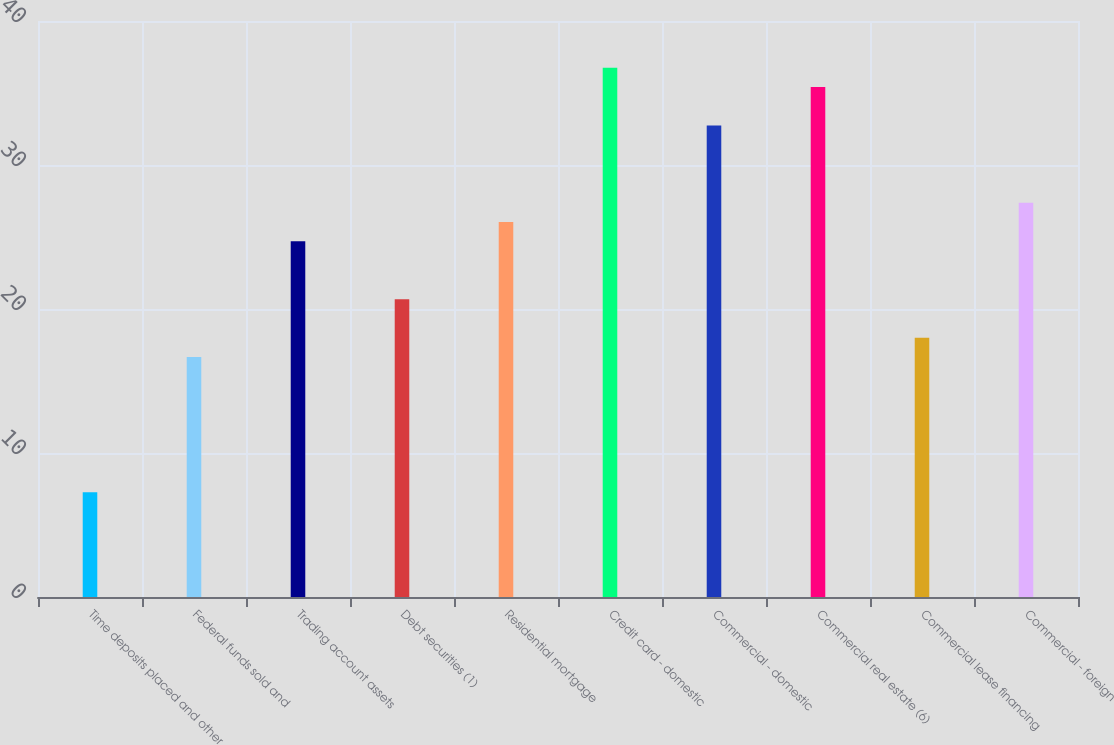Convert chart. <chart><loc_0><loc_0><loc_500><loc_500><bar_chart><fcel>Time deposits placed and other<fcel>Federal funds sold and<fcel>Trading account assets<fcel>Debt securities (1)<fcel>Residential mortgage<fcel>Credit card - domestic<fcel>Commercial - domestic<fcel>Commercial real estate (6)<fcel>Commercial lease financing<fcel>Commercial - foreign<nl><fcel>7.28<fcel>16.66<fcel>24.7<fcel>20.68<fcel>26.04<fcel>36.76<fcel>32.74<fcel>35.42<fcel>18<fcel>27.38<nl></chart> 